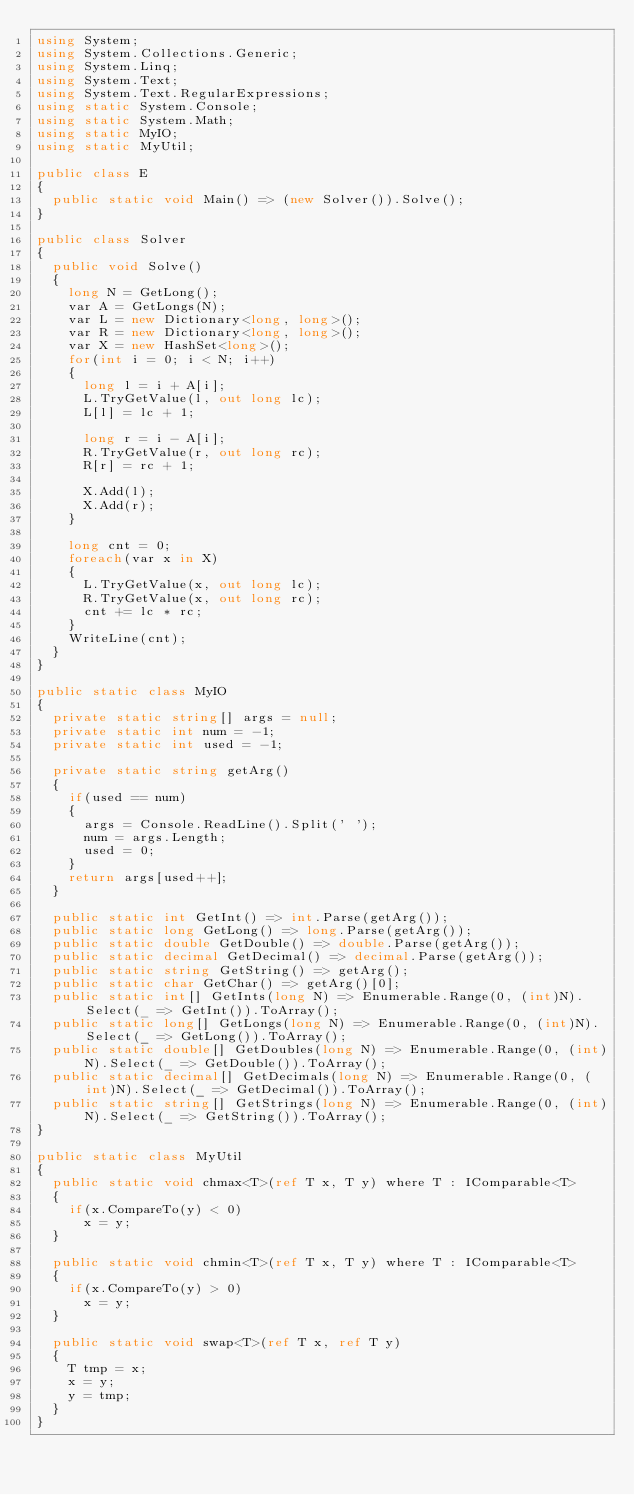Convert code to text. <code><loc_0><loc_0><loc_500><loc_500><_C#_>using System;
using System.Collections.Generic;
using System.Linq;
using System.Text;
using System.Text.RegularExpressions;
using static System.Console;
using static System.Math;
using static MyIO;
using static MyUtil;

public class E
{
	public static void Main() => (new Solver()).Solve();
}

public class Solver
{
	public void Solve()
	{
		long N = GetLong();
		var A = GetLongs(N);
		var L = new Dictionary<long, long>();
		var R = new Dictionary<long, long>();
		var X = new HashSet<long>();
		for(int i = 0; i < N; i++)
		{
			long l = i + A[i];
			L.TryGetValue(l, out long lc);
			L[l] = lc + 1;

			long r = i - A[i];
			R.TryGetValue(r, out long rc);
			R[r] = rc + 1;

			X.Add(l);
			X.Add(r);
		}

		long cnt = 0;
		foreach(var x in X)
		{
			L.TryGetValue(x, out long lc);
			R.TryGetValue(x, out long rc);
			cnt += lc * rc;
		}
		WriteLine(cnt);
	}
}

public static class MyIO
{
	private static string[] args = null;
	private static int num = -1;
	private static int used = -1;

	private static string getArg()
	{
		if(used == num)
		{
			args = Console.ReadLine().Split(' ');
			num = args.Length;
			used = 0;
		}
		return args[used++];
	}

	public static int GetInt() => int.Parse(getArg());
	public static long GetLong() => long.Parse(getArg());
	public static double GetDouble() => double.Parse(getArg());
	public static decimal GetDecimal() => decimal.Parse(getArg());
	public static string GetString() => getArg();
	public static char GetChar() => getArg()[0];
	public static int[] GetInts(long N) => Enumerable.Range(0, (int)N).Select(_ => GetInt()).ToArray();
	public static long[] GetLongs(long N) => Enumerable.Range(0, (int)N).Select(_ => GetLong()).ToArray();
	public static double[] GetDoubles(long N) => Enumerable.Range(0, (int)N).Select(_ => GetDouble()).ToArray();
	public static decimal[] GetDecimals(long N) => Enumerable.Range(0, (int)N).Select(_ => GetDecimal()).ToArray();
	public static string[] GetStrings(long N) => Enumerable.Range(0, (int)N).Select(_ => GetString()).ToArray();
}

public static class MyUtil
{
	public static void chmax<T>(ref T x, T y) where T : IComparable<T>
	{
		if(x.CompareTo(y) < 0)
			x = y;
	}

	public static void chmin<T>(ref T x, T y) where T : IComparable<T>
	{
		if(x.CompareTo(y) > 0)
			x = y;
	}

	public static void swap<T>(ref T x, ref T y)
	{
		T tmp = x;
		x = y;
		y = tmp;
	}
}</code> 